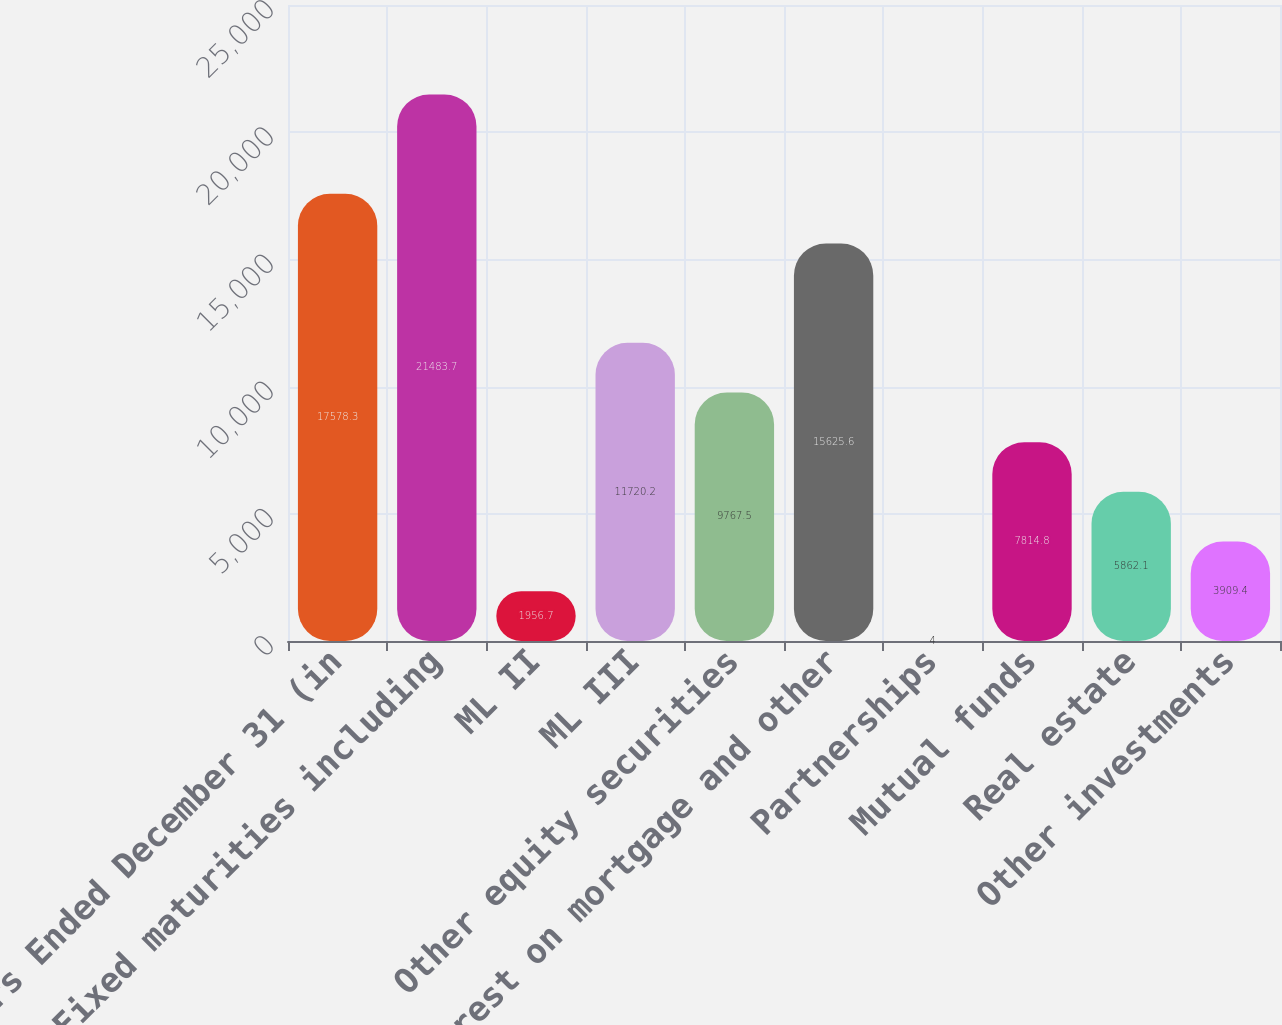Convert chart. <chart><loc_0><loc_0><loc_500><loc_500><bar_chart><fcel>Years Ended December 31 (in<fcel>Fixed maturities including<fcel>ML II<fcel>ML III<fcel>Other equity securities<fcel>Interest on mortgage and other<fcel>Partnerships<fcel>Mutual funds<fcel>Real estate<fcel>Other investments<nl><fcel>17578.3<fcel>21483.7<fcel>1956.7<fcel>11720.2<fcel>9767.5<fcel>15625.6<fcel>4<fcel>7814.8<fcel>5862.1<fcel>3909.4<nl></chart> 